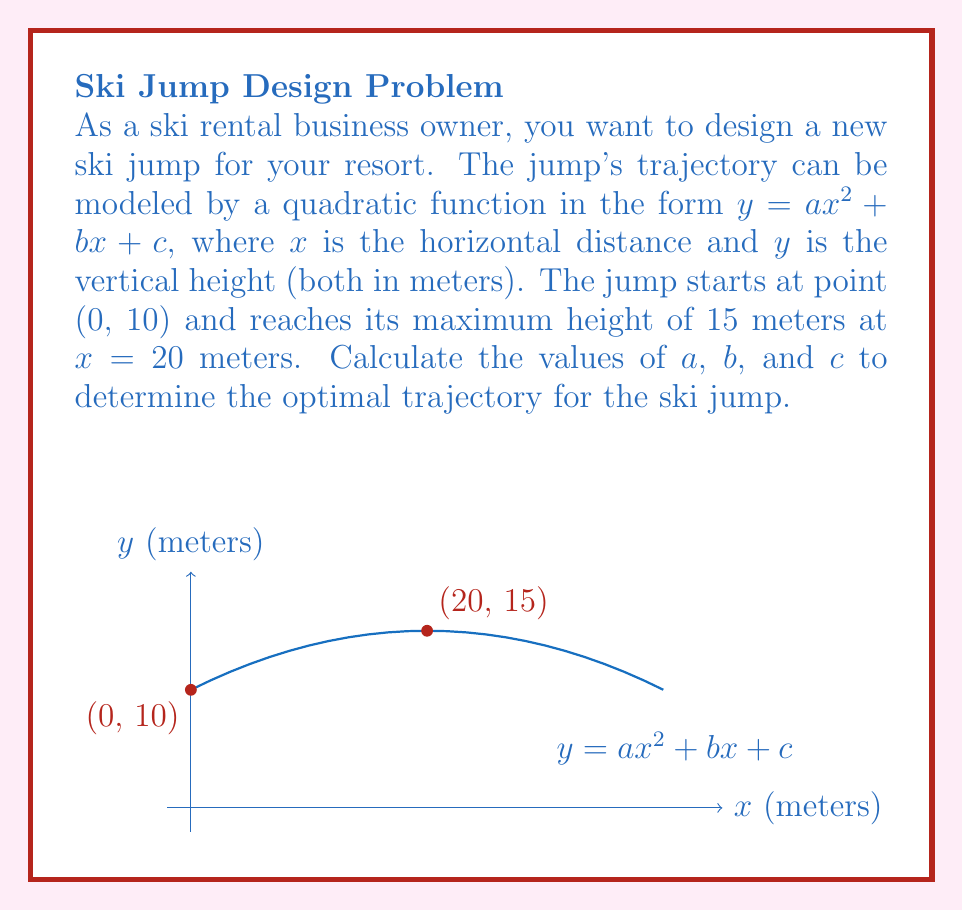Help me with this question. Let's solve this step-by-step:

1) We know three points on the parabola:
   (0, 10), (20, 15), and the vertex (20, 15)

2) Using the general form of a quadratic function: $y = ax^2 + bx + c$

3) The parabola passes through (0, 10), so:
   $10 = a(0)^2 + b(0) + c$
   $10 = c$

4) The vertex form of a quadratic function is: $y = a(x-h)^2 + k$
   Where (h,k) is the vertex. In this case, (20,15) is the vertex.

5) Rewriting our function in vertex form:
   $y = a(x-20)^2 + 15$

6) Expanding this:
   $y = a(x^2 - 40x + 400) + 15$
   $y = ax^2 - 40ax + 400a + 15$

7) Comparing with the general form $y = ax^2 + bx + c$:
   $b = -40a$
   $c = 400a + 15$

8) We know $c = 10$ from step 3, so:
   $10 = 400a + 15$
   $-5 = 400a$
   $a = -1/80 = -0.0125$

9) Now we can find $b$:
   $b = -40a = -40(-1/80) = 1/2 = 0.5$

10) Double-checking $c$:
    $c = 400(-1/80) + 15 = -5 + 15 = 10$

Therefore, $a = -1/80$, $b = 1/2$, and $c = 10$.
Answer: $a = -\frac{1}{80}$, $b = \frac{1}{2}$, $c = 10$ 